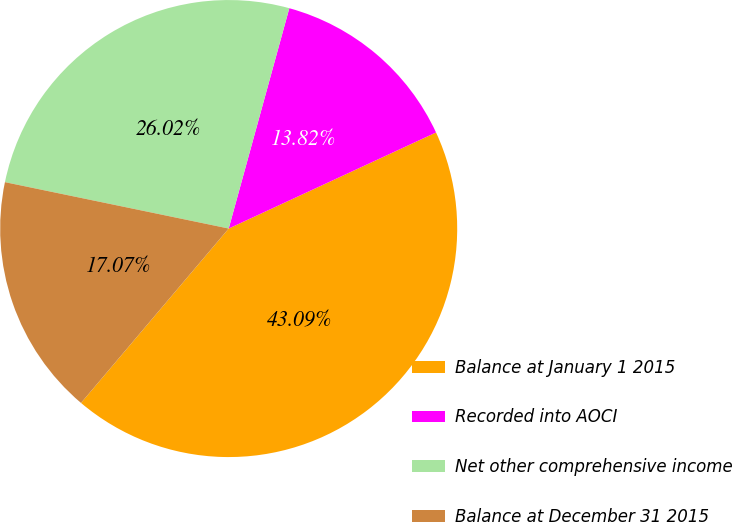Convert chart. <chart><loc_0><loc_0><loc_500><loc_500><pie_chart><fcel>Balance at January 1 2015<fcel>Recorded into AOCI<fcel>Net other comprehensive income<fcel>Balance at December 31 2015<nl><fcel>43.09%<fcel>13.82%<fcel>26.02%<fcel>17.07%<nl></chart> 